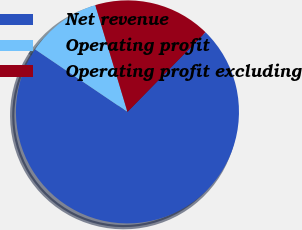Convert chart. <chart><loc_0><loc_0><loc_500><loc_500><pie_chart><fcel>Net revenue<fcel>Operating profit<fcel>Operating profit excluding<nl><fcel>72.14%<fcel>10.87%<fcel>16.99%<nl></chart> 